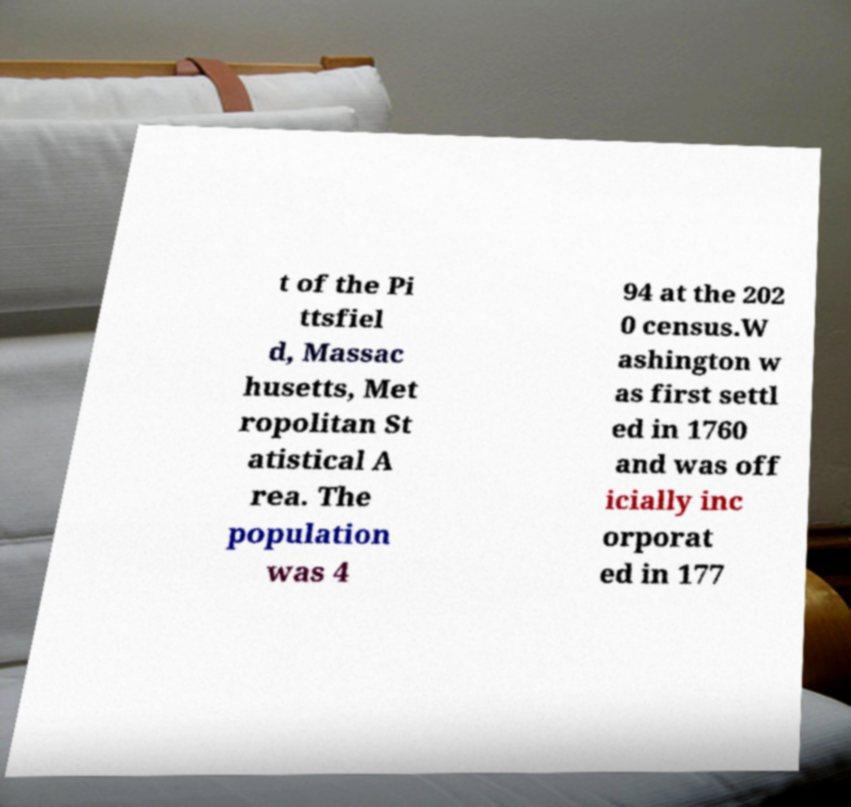Could you assist in decoding the text presented in this image and type it out clearly? t of the Pi ttsfiel d, Massac husetts, Met ropolitan St atistical A rea. The population was 4 94 at the 202 0 census.W ashington w as first settl ed in 1760 and was off icially inc orporat ed in 177 